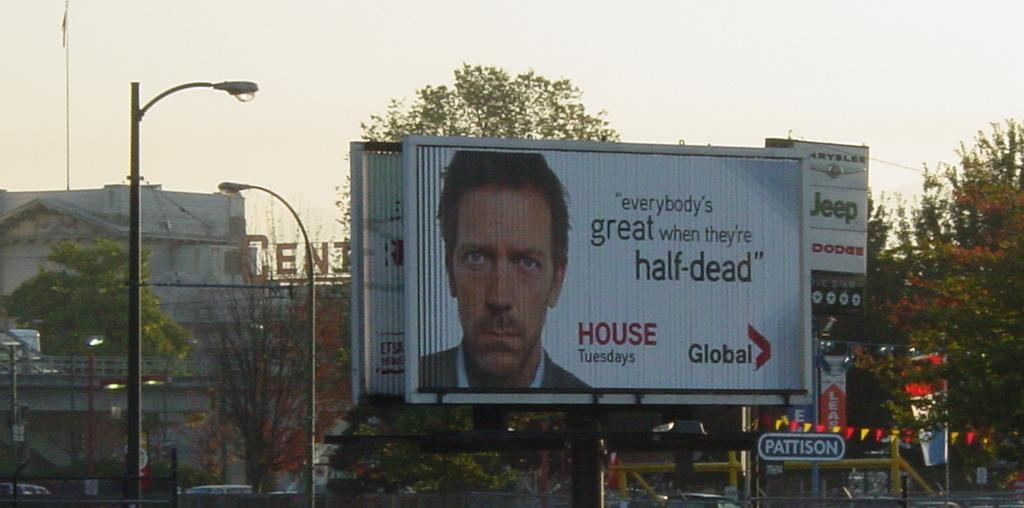<image>
Write a terse but informative summary of the picture. An advertisement for House is on a billboard in a city. 